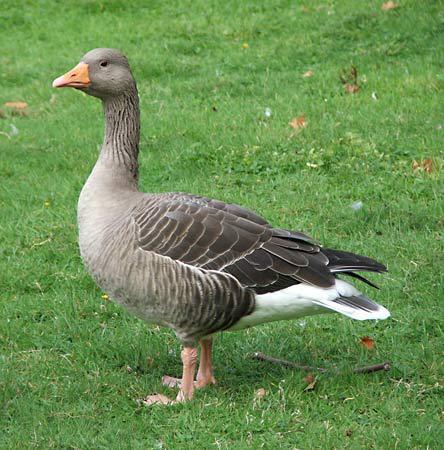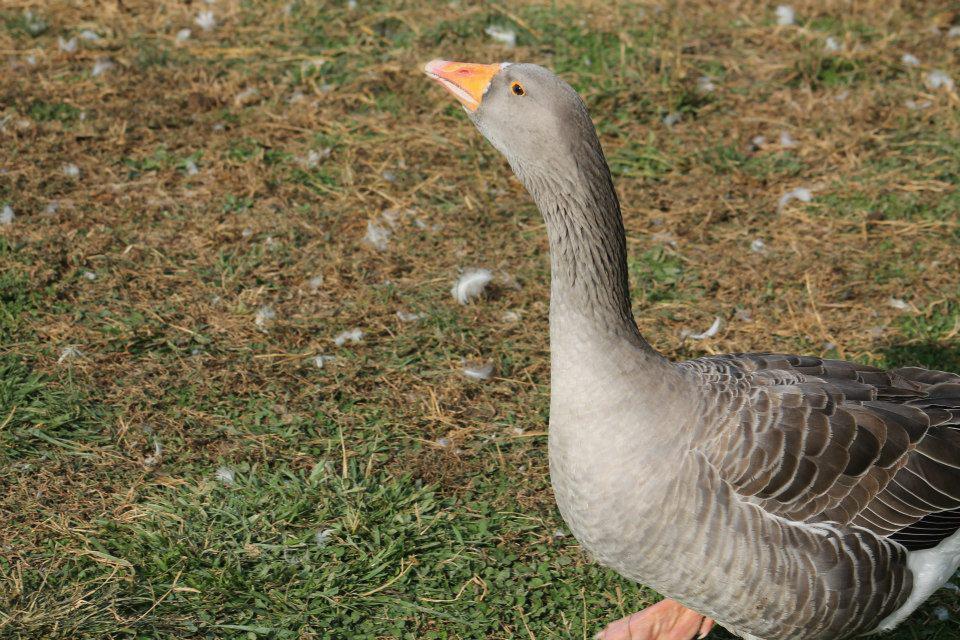The first image is the image on the left, the second image is the image on the right. Given the left and right images, does the statement "the goose on the right image is facing right" hold true? Answer yes or no. No. 